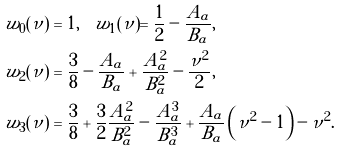<formula> <loc_0><loc_0><loc_500><loc_500>w _ { 0 } ( \nu ) & = 1 , \quad w _ { 1 } ( \nu ) = \frac { 1 } { 2 } - \frac { A _ { a } } { B _ { a } } , \\ w _ { 2 } ( \nu ) & = \frac { 3 } { 8 } - \frac { A _ { a } } { B _ { a } } + \frac { A _ { a } ^ { 2 } } { B _ { a } ^ { 2 } } - \frac { \nu ^ { 2 } } { 2 } , \\ w _ { 3 } ( \nu ) & = \frac { 3 } { 8 } + \frac { 3 } { 2 } \frac { A _ { a } ^ { 2 } } { B _ { a } ^ { 2 } } - \frac { A _ { a } ^ { 3 } } { B _ { a } ^ { 3 } } + \frac { A _ { a } } { B _ { a } } \left ( \nu ^ { 2 } - 1 \right ) - \nu ^ { 2 } .</formula> 